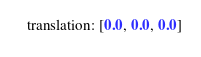<code> <loc_0><loc_0><loc_500><loc_500><_YAML_>  translation: [0.0, 0.0, 0.0]
</code> 